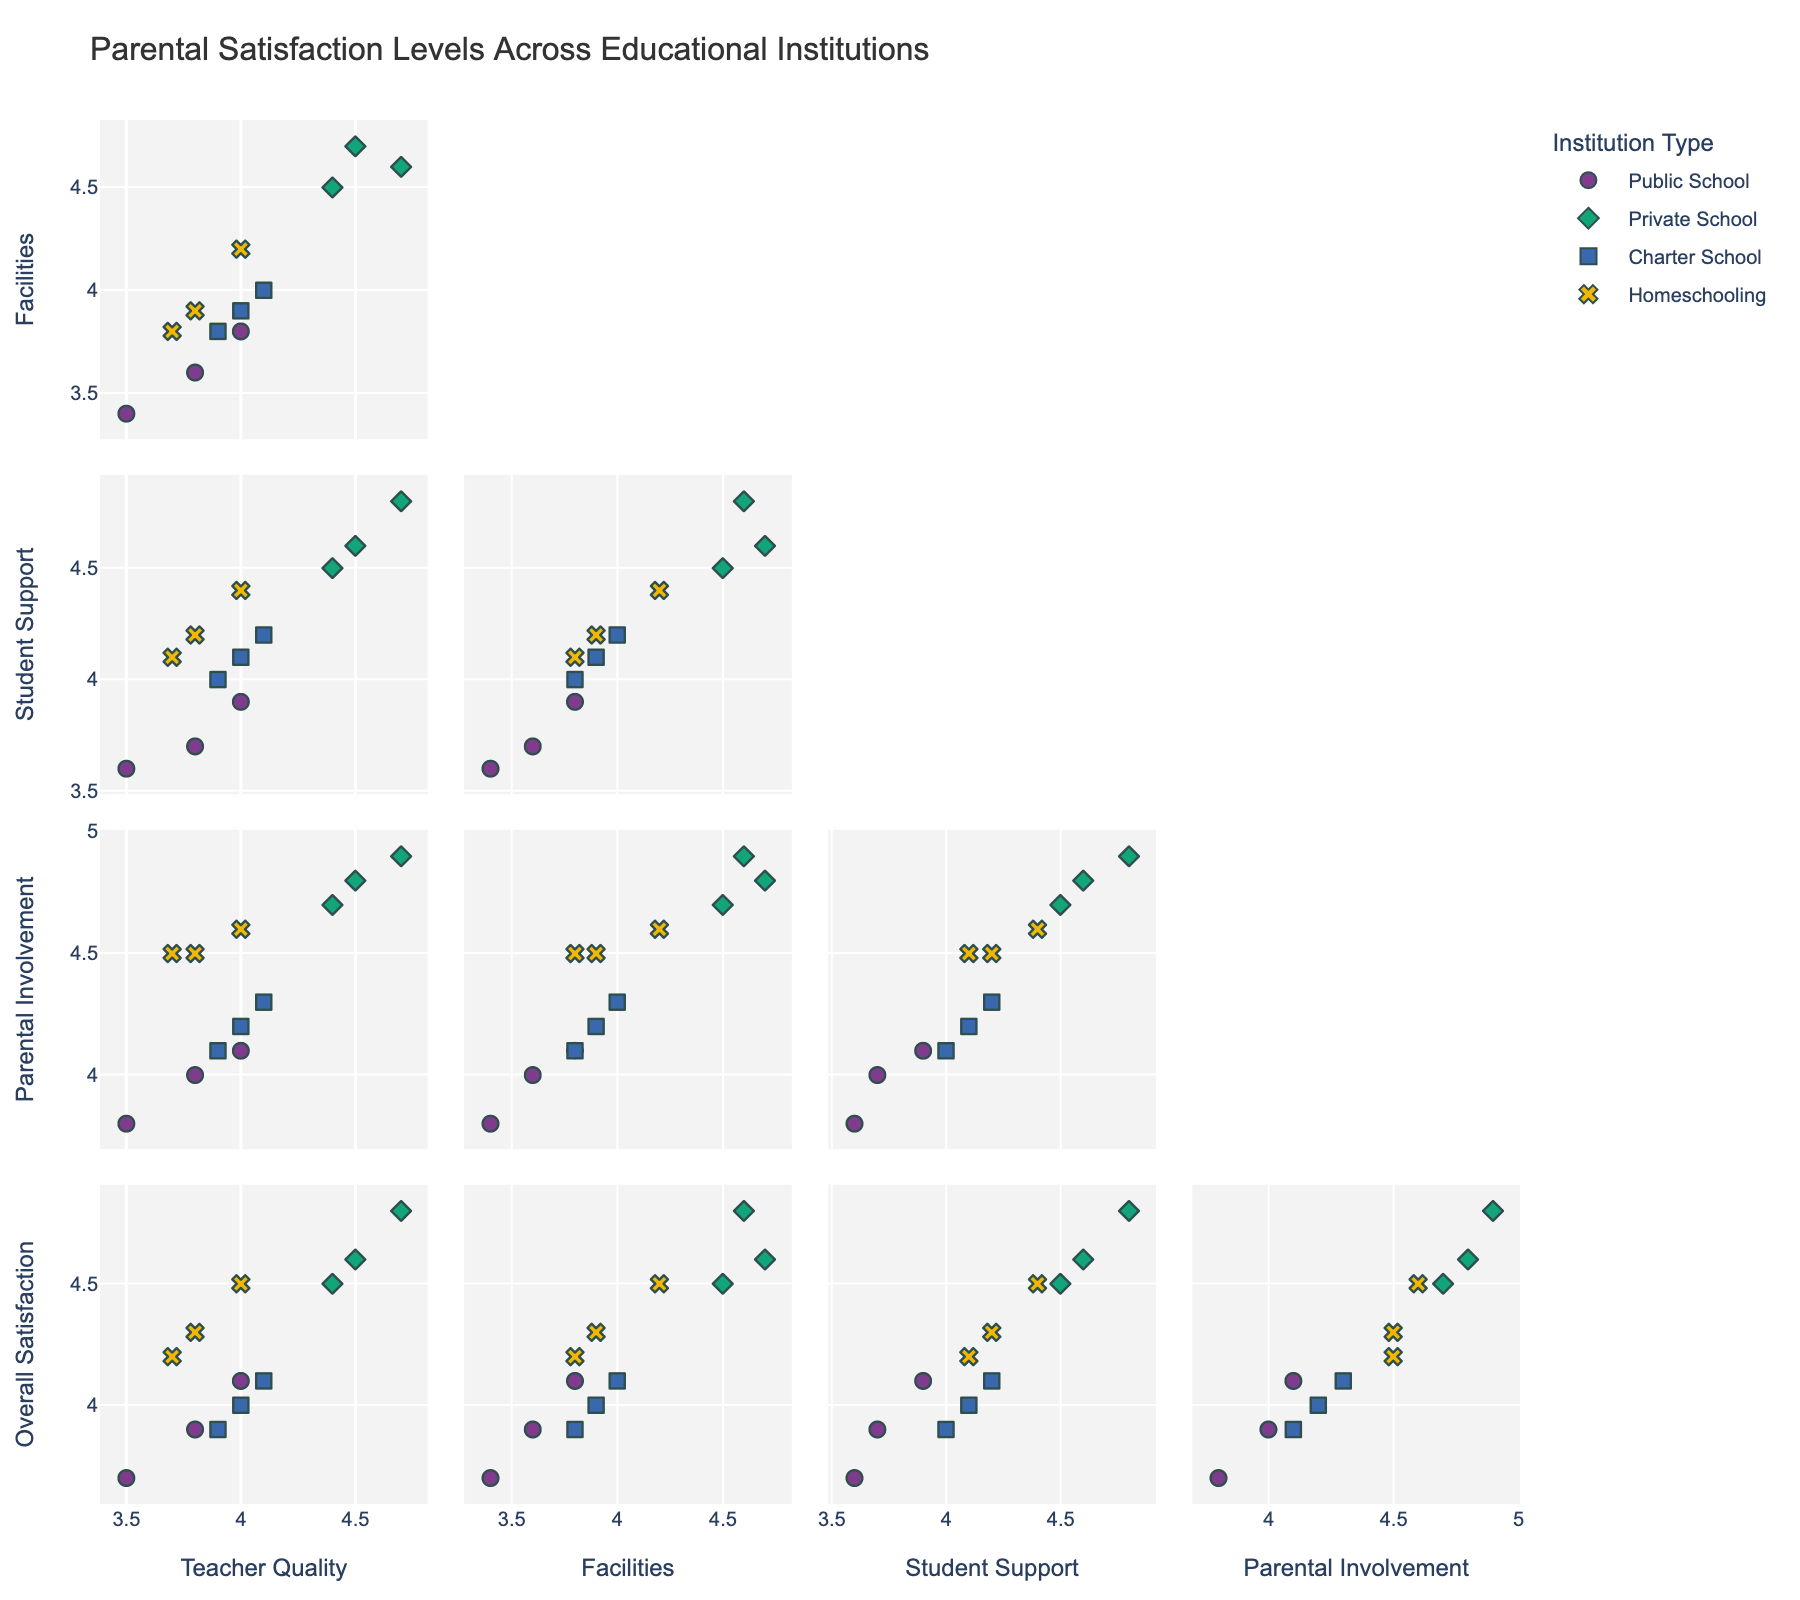What is the title of the scatter plot matrix? The figure's title is displayed prominently at the top and summarises the overall theme of the scatter plot matrix.
Answer: Parental Satisfaction Levels Across Educational Institutions How many institution types are compared in the figure? By examining the legend or different symbols and colors in the scatter plot matrix, we can determine the number of distinct groups representing institution types.
Answer: Four Which institution type has the highest overall satisfaction based on its median or average value? By comparing the "Overall Satisfaction" values for each institution type, we can determine which institution type generally scores highest.
Answer: Private School What is the relationship between Teacher Quality and Overall Satisfaction for Private Schools? By locating the scatter plot that compares 'Teacher Quality' and 'Overall Satisfaction' and focusing on the points colored and symbolized for Private Schools, we can observe if there's a trend or correlation.
Answer: Positive correlation Which type of institution shows the most variability in Parental Involvement? We need to compare the spread of data points along the 'Parental Involvement' axis for each institution type to see which has the widest range.
Answer: Homeschooling Is there a stronger correlation between Facilities and Overall Satisfaction or between Teacher Quality and Overall Satisfaction in Public Schools? By comparing the scatter plots between 'Facilities & Overall Satisfaction' and 'Teacher Quality & Overall Satisfaction' for Public Schools, we can observe which pair has data points more closely aligned along a trend line.
Answer: Teacher Quality and Overall Satisfaction Which institution type has the lowest average rating in Facilities? By examining the Facilities ratings for each institution type, we can identify which group has the lowest average score.
Answer: Public School Do any institution types show a clear outlier in any of the categories measured? By scanning each scatter plot, we can look for data points that are significantly different from others within the same institution type, indicating outliers.
Answer: No clear outlier What is the range of Overall Satisfaction scores for Homeschooling? Looking at the scatter plot or distribution of the 'Overall Satisfaction' scores specifically for Homeschooling, we determine the minimum and maximum values.
Answer: 4.2 to 4.5 Which institution type has the most clustered data points for Student Support and Teacher Quality? Reviewing the scatter plot that compares 'Student Support' and 'Teacher Quality' and noting which institution type's points are most closely grouped together will allow us to answer this.
Answer: Private School 